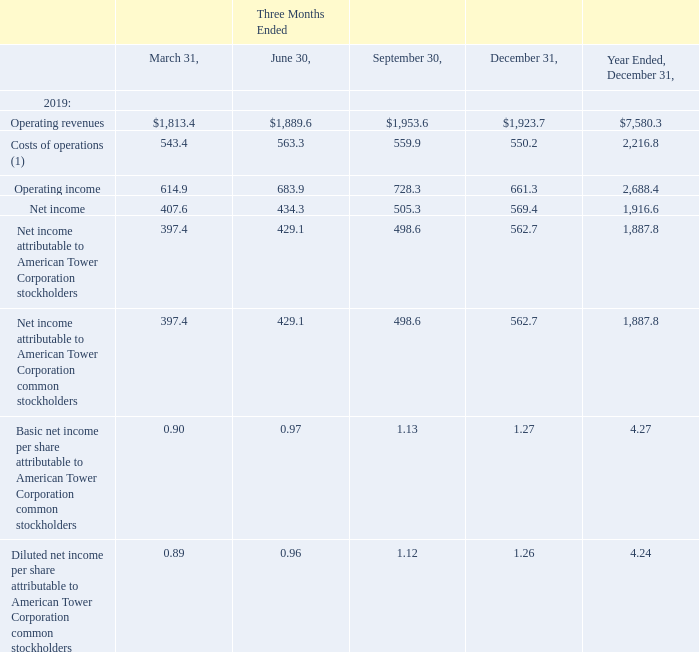AMERICAN TOWER CORPORATION AND SUBSIDIARIES NOTES TO CONSOLIDATED FINANCIAL STATEMENTS (Tabular amounts in millions, unless otherwise disclosed)
23. SELECTED QUARTERLY FINANCIAL DATA (UNAUDITED)
Selected quarterly financial data for the years ended December 31, 2019 and 2018 is as follows (in millions, except per share data):
(1) Represents Operating expenses, exclusive of Depreciation, amortization and accretion, Selling, general, administrative and development expense, and Other operating expenses.
What was the operating revenue in Three Months Ended  June?
Answer scale should be: million. $1,889.6. What was the operating income in Three Months Ended  March?
Answer scale should be: million. 614.9. What was the Basic net income per share attributable to American Tower Corporation common stockholders in Three Months Ended  September? 1.13. What was the change in Diluted net income per share attributable to American Tower Corporation common stockholders between Three Months Ended  March and June? 0.96-0.89
Answer: 0.07. What was the change in net income between Three Months Ended  June and September?
Answer scale should be: million. 505.3-434.3
Answer: 71. What was the percentage change in operating revenues between Three Months Ended  September and December?
Answer scale should be: percent. ($1,923.7-$1,953.6)/$1,953.6
Answer: -1.53. 